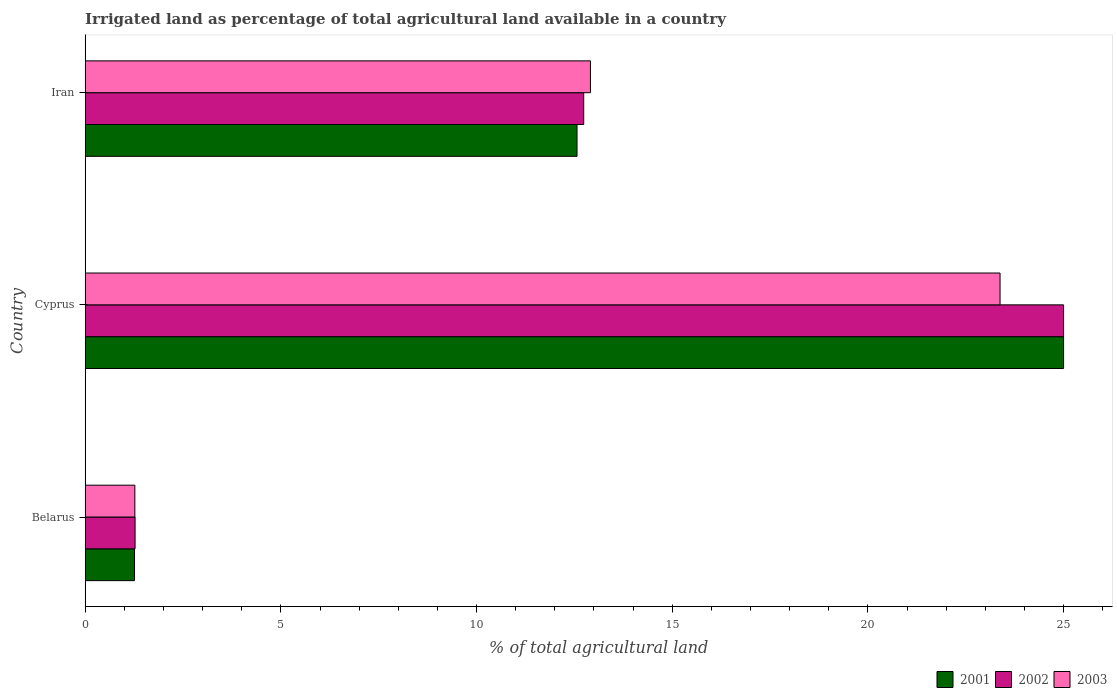How many groups of bars are there?
Offer a terse response. 3. How many bars are there on the 1st tick from the top?
Your answer should be very brief. 3. What is the label of the 1st group of bars from the top?
Offer a terse response. Iran. What is the percentage of irrigated land in 2002 in Belarus?
Provide a succinct answer. 1.27. Across all countries, what is the minimum percentage of irrigated land in 2002?
Keep it short and to the point. 1.27. In which country was the percentage of irrigated land in 2001 maximum?
Your answer should be very brief. Cyprus. In which country was the percentage of irrigated land in 2003 minimum?
Make the answer very short. Belarus. What is the total percentage of irrigated land in 2001 in the graph?
Offer a terse response. 38.83. What is the difference between the percentage of irrigated land in 2001 in Belarus and that in Cyprus?
Provide a short and direct response. -23.74. What is the difference between the percentage of irrigated land in 2002 in Belarus and the percentage of irrigated land in 2003 in Iran?
Make the answer very short. -11.64. What is the average percentage of irrigated land in 2001 per country?
Your response must be concise. 12.94. What is the difference between the percentage of irrigated land in 2003 and percentage of irrigated land in 2002 in Cyprus?
Ensure brevity in your answer.  -1.62. What is the ratio of the percentage of irrigated land in 2002 in Cyprus to that in Iran?
Your answer should be compact. 1.96. Is the percentage of irrigated land in 2002 in Cyprus less than that in Iran?
Keep it short and to the point. No. Is the difference between the percentage of irrigated land in 2003 in Cyprus and Iran greater than the difference between the percentage of irrigated land in 2002 in Cyprus and Iran?
Make the answer very short. No. What is the difference between the highest and the second highest percentage of irrigated land in 2001?
Provide a short and direct response. 12.43. What is the difference between the highest and the lowest percentage of irrigated land in 2003?
Keep it short and to the point. 22.11. Is the sum of the percentage of irrigated land in 2001 in Belarus and Iran greater than the maximum percentage of irrigated land in 2002 across all countries?
Keep it short and to the point. No. What does the 1st bar from the top in Cyprus represents?
Keep it short and to the point. 2003. What does the 3rd bar from the bottom in Iran represents?
Give a very brief answer. 2003. Is it the case that in every country, the sum of the percentage of irrigated land in 2002 and percentage of irrigated land in 2001 is greater than the percentage of irrigated land in 2003?
Your answer should be very brief. Yes. Are all the bars in the graph horizontal?
Offer a very short reply. Yes. What is the difference between two consecutive major ticks on the X-axis?
Your answer should be very brief. 5. How many legend labels are there?
Give a very brief answer. 3. How are the legend labels stacked?
Your response must be concise. Horizontal. What is the title of the graph?
Provide a succinct answer. Irrigated land as percentage of total agricultural land available in a country. What is the label or title of the X-axis?
Ensure brevity in your answer.  % of total agricultural land. What is the % of total agricultural land in 2001 in Belarus?
Provide a short and direct response. 1.26. What is the % of total agricultural land in 2002 in Belarus?
Provide a short and direct response. 1.27. What is the % of total agricultural land in 2003 in Belarus?
Provide a short and direct response. 1.27. What is the % of total agricultural land of 2002 in Cyprus?
Provide a short and direct response. 25. What is the % of total agricultural land in 2003 in Cyprus?
Your response must be concise. 23.38. What is the % of total agricultural land in 2001 in Iran?
Your answer should be compact. 12.57. What is the % of total agricultural land in 2002 in Iran?
Keep it short and to the point. 12.74. What is the % of total agricultural land of 2003 in Iran?
Your answer should be very brief. 12.91. Across all countries, what is the maximum % of total agricultural land of 2003?
Give a very brief answer. 23.38. Across all countries, what is the minimum % of total agricultural land in 2001?
Ensure brevity in your answer.  1.26. Across all countries, what is the minimum % of total agricultural land in 2002?
Keep it short and to the point. 1.27. Across all countries, what is the minimum % of total agricultural land of 2003?
Give a very brief answer. 1.27. What is the total % of total agricultural land in 2001 in the graph?
Keep it short and to the point. 38.83. What is the total % of total agricultural land in 2002 in the graph?
Your answer should be very brief. 39.01. What is the total % of total agricultural land in 2003 in the graph?
Ensure brevity in your answer.  37.56. What is the difference between the % of total agricultural land of 2001 in Belarus and that in Cyprus?
Provide a succinct answer. -23.74. What is the difference between the % of total agricultural land of 2002 in Belarus and that in Cyprus?
Offer a terse response. -23.73. What is the difference between the % of total agricultural land of 2003 in Belarus and that in Cyprus?
Your response must be concise. -22.11. What is the difference between the % of total agricultural land of 2001 in Belarus and that in Iran?
Give a very brief answer. -11.31. What is the difference between the % of total agricultural land in 2002 in Belarus and that in Iran?
Make the answer very short. -11.46. What is the difference between the % of total agricultural land of 2003 in Belarus and that in Iran?
Offer a terse response. -11.64. What is the difference between the % of total agricultural land in 2001 in Cyprus and that in Iran?
Make the answer very short. 12.43. What is the difference between the % of total agricultural land in 2002 in Cyprus and that in Iran?
Offer a very short reply. 12.26. What is the difference between the % of total agricultural land in 2003 in Cyprus and that in Iran?
Give a very brief answer. 10.47. What is the difference between the % of total agricultural land in 2001 in Belarus and the % of total agricultural land in 2002 in Cyprus?
Your response must be concise. -23.74. What is the difference between the % of total agricultural land of 2001 in Belarus and the % of total agricultural land of 2003 in Cyprus?
Give a very brief answer. -22.12. What is the difference between the % of total agricultural land of 2002 in Belarus and the % of total agricultural land of 2003 in Cyprus?
Give a very brief answer. -22.1. What is the difference between the % of total agricultural land in 2001 in Belarus and the % of total agricultural land in 2002 in Iran?
Keep it short and to the point. -11.48. What is the difference between the % of total agricultural land in 2001 in Belarus and the % of total agricultural land in 2003 in Iran?
Provide a succinct answer. -11.65. What is the difference between the % of total agricultural land of 2002 in Belarus and the % of total agricultural land of 2003 in Iran?
Provide a succinct answer. -11.64. What is the difference between the % of total agricultural land in 2001 in Cyprus and the % of total agricultural land in 2002 in Iran?
Offer a very short reply. 12.26. What is the difference between the % of total agricultural land of 2001 in Cyprus and the % of total agricultural land of 2003 in Iran?
Your response must be concise. 12.09. What is the difference between the % of total agricultural land in 2002 in Cyprus and the % of total agricultural land in 2003 in Iran?
Ensure brevity in your answer.  12.09. What is the average % of total agricultural land of 2001 per country?
Offer a terse response. 12.94. What is the average % of total agricultural land of 2002 per country?
Give a very brief answer. 13. What is the average % of total agricultural land of 2003 per country?
Provide a short and direct response. 12.52. What is the difference between the % of total agricultural land in 2001 and % of total agricultural land in 2002 in Belarus?
Your response must be concise. -0.01. What is the difference between the % of total agricultural land in 2001 and % of total agricultural land in 2003 in Belarus?
Give a very brief answer. -0.01. What is the difference between the % of total agricultural land in 2002 and % of total agricultural land in 2003 in Belarus?
Give a very brief answer. 0.01. What is the difference between the % of total agricultural land in 2001 and % of total agricultural land in 2003 in Cyprus?
Provide a short and direct response. 1.62. What is the difference between the % of total agricultural land of 2002 and % of total agricultural land of 2003 in Cyprus?
Provide a short and direct response. 1.62. What is the difference between the % of total agricultural land of 2001 and % of total agricultural land of 2002 in Iran?
Provide a short and direct response. -0.17. What is the difference between the % of total agricultural land of 2001 and % of total agricultural land of 2003 in Iran?
Give a very brief answer. -0.34. What is the difference between the % of total agricultural land in 2002 and % of total agricultural land in 2003 in Iran?
Make the answer very short. -0.17. What is the ratio of the % of total agricultural land in 2001 in Belarus to that in Cyprus?
Your answer should be compact. 0.05. What is the ratio of the % of total agricultural land in 2002 in Belarus to that in Cyprus?
Give a very brief answer. 0.05. What is the ratio of the % of total agricultural land in 2003 in Belarus to that in Cyprus?
Make the answer very short. 0.05. What is the ratio of the % of total agricultural land of 2001 in Belarus to that in Iran?
Ensure brevity in your answer.  0.1. What is the ratio of the % of total agricultural land in 2002 in Belarus to that in Iran?
Make the answer very short. 0.1. What is the ratio of the % of total agricultural land in 2003 in Belarus to that in Iran?
Your answer should be compact. 0.1. What is the ratio of the % of total agricultural land of 2001 in Cyprus to that in Iran?
Your answer should be compact. 1.99. What is the ratio of the % of total agricultural land in 2002 in Cyprus to that in Iran?
Give a very brief answer. 1.96. What is the ratio of the % of total agricultural land of 2003 in Cyprus to that in Iran?
Make the answer very short. 1.81. What is the difference between the highest and the second highest % of total agricultural land in 2001?
Ensure brevity in your answer.  12.43. What is the difference between the highest and the second highest % of total agricultural land of 2002?
Ensure brevity in your answer.  12.26. What is the difference between the highest and the second highest % of total agricultural land of 2003?
Your answer should be very brief. 10.47. What is the difference between the highest and the lowest % of total agricultural land of 2001?
Provide a succinct answer. 23.74. What is the difference between the highest and the lowest % of total agricultural land of 2002?
Your answer should be compact. 23.73. What is the difference between the highest and the lowest % of total agricultural land in 2003?
Keep it short and to the point. 22.11. 